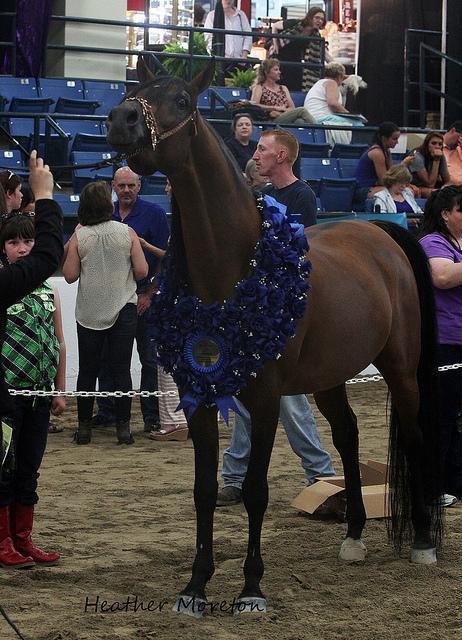How many people can you see?
Give a very brief answer. 10. 